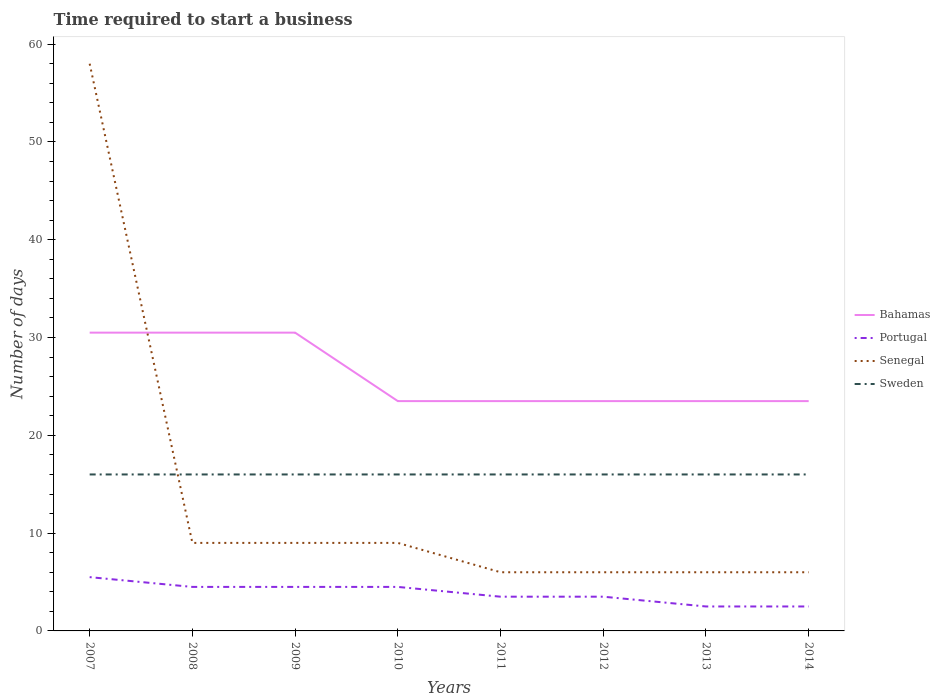Is the number of lines equal to the number of legend labels?
Provide a short and direct response. Yes. Across all years, what is the maximum number of days required to start a business in Portugal?
Give a very brief answer. 2.5. What is the difference between the highest and the second highest number of days required to start a business in Bahamas?
Ensure brevity in your answer.  7. Is the number of days required to start a business in Portugal strictly greater than the number of days required to start a business in Senegal over the years?
Offer a very short reply. Yes. How many lines are there?
Keep it short and to the point. 4. What is the difference between two consecutive major ticks on the Y-axis?
Give a very brief answer. 10. Are the values on the major ticks of Y-axis written in scientific E-notation?
Give a very brief answer. No. Does the graph contain any zero values?
Offer a very short reply. No. Does the graph contain grids?
Your answer should be compact. No. How are the legend labels stacked?
Provide a short and direct response. Vertical. What is the title of the graph?
Make the answer very short. Time required to start a business. Does "Fiji" appear as one of the legend labels in the graph?
Offer a very short reply. No. What is the label or title of the X-axis?
Provide a succinct answer. Years. What is the label or title of the Y-axis?
Keep it short and to the point. Number of days. What is the Number of days in Bahamas in 2007?
Keep it short and to the point. 30.5. What is the Number of days in Portugal in 2007?
Offer a very short reply. 5.5. What is the Number of days of Senegal in 2007?
Give a very brief answer. 58. What is the Number of days of Bahamas in 2008?
Ensure brevity in your answer.  30.5. What is the Number of days of Portugal in 2008?
Give a very brief answer. 4.5. What is the Number of days in Sweden in 2008?
Your answer should be very brief. 16. What is the Number of days of Bahamas in 2009?
Your answer should be very brief. 30.5. What is the Number of days in Portugal in 2009?
Your answer should be compact. 4.5. What is the Number of days of Bahamas in 2010?
Offer a very short reply. 23.5. What is the Number of days in Portugal in 2010?
Offer a very short reply. 4.5. What is the Number of days in Senegal in 2010?
Keep it short and to the point. 9. What is the Number of days in Bahamas in 2011?
Your answer should be very brief. 23.5. What is the Number of days in Senegal in 2011?
Offer a terse response. 6. What is the Number of days of Bahamas in 2012?
Ensure brevity in your answer.  23.5. What is the Number of days in Portugal in 2012?
Keep it short and to the point. 3.5. What is the Number of days in Sweden in 2012?
Offer a terse response. 16. What is the Number of days in Portugal in 2013?
Make the answer very short. 2.5. What is the Number of days in Senegal in 2013?
Offer a terse response. 6. What is the Number of days of Sweden in 2013?
Provide a succinct answer. 16. What is the Number of days in Bahamas in 2014?
Offer a very short reply. 23.5. What is the Number of days in Portugal in 2014?
Your answer should be very brief. 2.5. What is the Number of days in Sweden in 2014?
Your answer should be very brief. 16. Across all years, what is the maximum Number of days in Bahamas?
Make the answer very short. 30.5. Across all years, what is the maximum Number of days of Sweden?
Ensure brevity in your answer.  16. Across all years, what is the minimum Number of days of Bahamas?
Keep it short and to the point. 23.5. Across all years, what is the minimum Number of days of Portugal?
Provide a short and direct response. 2.5. Across all years, what is the minimum Number of days in Senegal?
Provide a short and direct response. 6. Across all years, what is the minimum Number of days of Sweden?
Keep it short and to the point. 16. What is the total Number of days in Bahamas in the graph?
Ensure brevity in your answer.  209. What is the total Number of days in Portugal in the graph?
Offer a terse response. 31. What is the total Number of days of Senegal in the graph?
Your answer should be compact. 109. What is the total Number of days of Sweden in the graph?
Provide a succinct answer. 128. What is the difference between the Number of days in Sweden in 2007 and that in 2008?
Ensure brevity in your answer.  0. What is the difference between the Number of days in Senegal in 2007 and that in 2009?
Keep it short and to the point. 49. What is the difference between the Number of days in Sweden in 2007 and that in 2010?
Offer a terse response. 0. What is the difference between the Number of days of Bahamas in 2007 and that in 2011?
Ensure brevity in your answer.  7. What is the difference between the Number of days of Portugal in 2007 and that in 2011?
Give a very brief answer. 2. What is the difference between the Number of days of Sweden in 2007 and that in 2011?
Give a very brief answer. 0. What is the difference between the Number of days of Portugal in 2007 and that in 2012?
Ensure brevity in your answer.  2. What is the difference between the Number of days of Sweden in 2007 and that in 2012?
Make the answer very short. 0. What is the difference between the Number of days in Senegal in 2007 and that in 2014?
Your answer should be very brief. 52. What is the difference between the Number of days in Sweden in 2007 and that in 2014?
Ensure brevity in your answer.  0. What is the difference between the Number of days of Senegal in 2008 and that in 2009?
Provide a succinct answer. 0. What is the difference between the Number of days of Sweden in 2008 and that in 2009?
Provide a short and direct response. 0. What is the difference between the Number of days in Sweden in 2008 and that in 2010?
Give a very brief answer. 0. What is the difference between the Number of days in Bahamas in 2008 and that in 2011?
Ensure brevity in your answer.  7. What is the difference between the Number of days in Senegal in 2008 and that in 2011?
Keep it short and to the point. 3. What is the difference between the Number of days of Bahamas in 2008 and that in 2012?
Offer a very short reply. 7. What is the difference between the Number of days of Senegal in 2008 and that in 2012?
Provide a short and direct response. 3. What is the difference between the Number of days of Portugal in 2008 and that in 2013?
Keep it short and to the point. 2. What is the difference between the Number of days in Senegal in 2008 and that in 2013?
Offer a very short reply. 3. What is the difference between the Number of days in Bahamas in 2008 and that in 2014?
Keep it short and to the point. 7. What is the difference between the Number of days of Portugal in 2008 and that in 2014?
Keep it short and to the point. 2. What is the difference between the Number of days in Senegal in 2008 and that in 2014?
Provide a short and direct response. 3. What is the difference between the Number of days of Sweden in 2008 and that in 2014?
Give a very brief answer. 0. What is the difference between the Number of days in Bahamas in 2009 and that in 2010?
Provide a short and direct response. 7. What is the difference between the Number of days of Sweden in 2009 and that in 2010?
Make the answer very short. 0. What is the difference between the Number of days of Bahamas in 2009 and that in 2011?
Your response must be concise. 7. What is the difference between the Number of days in Bahamas in 2009 and that in 2012?
Your answer should be very brief. 7. What is the difference between the Number of days of Portugal in 2009 and that in 2012?
Your answer should be very brief. 1. What is the difference between the Number of days of Senegal in 2009 and that in 2012?
Provide a succinct answer. 3. What is the difference between the Number of days in Senegal in 2009 and that in 2013?
Keep it short and to the point. 3. What is the difference between the Number of days in Bahamas in 2010 and that in 2011?
Provide a short and direct response. 0. What is the difference between the Number of days of Portugal in 2010 and that in 2011?
Your answer should be compact. 1. What is the difference between the Number of days in Senegal in 2010 and that in 2011?
Offer a terse response. 3. What is the difference between the Number of days of Sweden in 2010 and that in 2011?
Your answer should be compact. 0. What is the difference between the Number of days of Bahamas in 2010 and that in 2012?
Make the answer very short. 0. What is the difference between the Number of days of Sweden in 2010 and that in 2012?
Your answer should be compact. 0. What is the difference between the Number of days in Bahamas in 2010 and that in 2013?
Provide a short and direct response. 0. What is the difference between the Number of days in Portugal in 2010 and that in 2013?
Give a very brief answer. 2. What is the difference between the Number of days in Senegal in 2010 and that in 2013?
Keep it short and to the point. 3. What is the difference between the Number of days of Senegal in 2010 and that in 2014?
Your response must be concise. 3. What is the difference between the Number of days in Portugal in 2011 and that in 2012?
Give a very brief answer. 0. What is the difference between the Number of days in Senegal in 2011 and that in 2012?
Your answer should be compact. 0. What is the difference between the Number of days in Sweden in 2011 and that in 2012?
Make the answer very short. 0. What is the difference between the Number of days of Bahamas in 2011 and that in 2013?
Your answer should be very brief. 0. What is the difference between the Number of days of Portugal in 2011 and that in 2013?
Provide a succinct answer. 1. What is the difference between the Number of days of Portugal in 2011 and that in 2014?
Keep it short and to the point. 1. What is the difference between the Number of days in Senegal in 2011 and that in 2014?
Give a very brief answer. 0. What is the difference between the Number of days in Sweden in 2011 and that in 2014?
Your answer should be very brief. 0. What is the difference between the Number of days of Bahamas in 2012 and that in 2013?
Make the answer very short. 0. What is the difference between the Number of days in Sweden in 2012 and that in 2013?
Ensure brevity in your answer.  0. What is the difference between the Number of days in Portugal in 2012 and that in 2014?
Your answer should be compact. 1. What is the difference between the Number of days of Sweden in 2012 and that in 2014?
Give a very brief answer. 0. What is the difference between the Number of days in Portugal in 2013 and that in 2014?
Ensure brevity in your answer.  0. What is the difference between the Number of days in Senegal in 2013 and that in 2014?
Provide a succinct answer. 0. What is the difference between the Number of days of Bahamas in 2007 and the Number of days of Portugal in 2008?
Your response must be concise. 26. What is the difference between the Number of days of Bahamas in 2007 and the Number of days of Senegal in 2008?
Offer a very short reply. 21.5. What is the difference between the Number of days of Bahamas in 2007 and the Number of days of Sweden in 2008?
Your answer should be very brief. 14.5. What is the difference between the Number of days of Portugal in 2007 and the Number of days of Senegal in 2008?
Offer a terse response. -3.5. What is the difference between the Number of days of Portugal in 2007 and the Number of days of Sweden in 2008?
Provide a succinct answer. -10.5. What is the difference between the Number of days in Senegal in 2007 and the Number of days in Sweden in 2008?
Your response must be concise. 42. What is the difference between the Number of days of Bahamas in 2007 and the Number of days of Senegal in 2009?
Make the answer very short. 21.5. What is the difference between the Number of days in Bahamas in 2007 and the Number of days in Sweden in 2009?
Your answer should be compact. 14.5. What is the difference between the Number of days in Senegal in 2007 and the Number of days in Sweden in 2009?
Your answer should be very brief. 42. What is the difference between the Number of days of Bahamas in 2007 and the Number of days of Sweden in 2010?
Provide a short and direct response. 14.5. What is the difference between the Number of days in Portugal in 2007 and the Number of days in Sweden in 2010?
Your answer should be very brief. -10.5. What is the difference between the Number of days of Bahamas in 2007 and the Number of days of Portugal in 2011?
Make the answer very short. 27. What is the difference between the Number of days of Bahamas in 2007 and the Number of days of Senegal in 2011?
Offer a very short reply. 24.5. What is the difference between the Number of days of Bahamas in 2007 and the Number of days of Sweden in 2011?
Offer a very short reply. 14.5. What is the difference between the Number of days in Portugal in 2007 and the Number of days in Sweden in 2011?
Give a very brief answer. -10.5. What is the difference between the Number of days of Bahamas in 2007 and the Number of days of Portugal in 2012?
Offer a terse response. 27. What is the difference between the Number of days in Bahamas in 2007 and the Number of days in Senegal in 2012?
Provide a succinct answer. 24.5. What is the difference between the Number of days in Portugal in 2007 and the Number of days in Senegal in 2012?
Make the answer very short. -0.5. What is the difference between the Number of days of Portugal in 2007 and the Number of days of Sweden in 2012?
Give a very brief answer. -10.5. What is the difference between the Number of days of Senegal in 2007 and the Number of days of Sweden in 2012?
Ensure brevity in your answer.  42. What is the difference between the Number of days of Portugal in 2007 and the Number of days of Senegal in 2013?
Make the answer very short. -0.5. What is the difference between the Number of days of Senegal in 2007 and the Number of days of Sweden in 2013?
Give a very brief answer. 42. What is the difference between the Number of days in Bahamas in 2007 and the Number of days in Sweden in 2014?
Provide a succinct answer. 14.5. What is the difference between the Number of days of Portugal in 2007 and the Number of days of Sweden in 2014?
Offer a very short reply. -10.5. What is the difference between the Number of days in Portugal in 2008 and the Number of days in Senegal in 2009?
Provide a succinct answer. -4.5. What is the difference between the Number of days in Senegal in 2008 and the Number of days in Sweden in 2009?
Give a very brief answer. -7. What is the difference between the Number of days of Bahamas in 2008 and the Number of days of Portugal in 2010?
Ensure brevity in your answer.  26. What is the difference between the Number of days of Bahamas in 2008 and the Number of days of Sweden in 2010?
Keep it short and to the point. 14.5. What is the difference between the Number of days in Portugal in 2008 and the Number of days in Senegal in 2010?
Provide a short and direct response. -4.5. What is the difference between the Number of days of Portugal in 2008 and the Number of days of Sweden in 2010?
Make the answer very short. -11.5. What is the difference between the Number of days of Senegal in 2008 and the Number of days of Sweden in 2010?
Your answer should be compact. -7. What is the difference between the Number of days in Bahamas in 2008 and the Number of days in Portugal in 2011?
Your answer should be compact. 27. What is the difference between the Number of days of Bahamas in 2008 and the Number of days of Senegal in 2011?
Provide a short and direct response. 24.5. What is the difference between the Number of days in Portugal in 2008 and the Number of days in Senegal in 2011?
Your answer should be compact. -1.5. What is the difference between the Number of days in Portugal in 2008 and the Number of days in Sweden in 2011?
Your response must be concise. -11.5. What is the difference between the Number of days of Senegal in 2008 and the Number of days of Sweden in 2011?
Your answer should be compact. -7. What is the difference between the Number of days in Bahamas in 2008 and the Number of days in Senegal in 2012?
Your answer should be compact. 24.5. What is the difference between the Number of days in Bahamas in 2008 and the Number of days in Sweden in 2012?
Give a very brief answer. 14.5. What is the difference between the Number of days in Bahamas in 2008 and the Number of days in Portugal in 2013?
Offer a very short reply. 28. What is the difference between the Number of days of Bahamas in 2008 and the Number of days of Sweden in 2013?
Your answer should be compact. 14.5. What is the difference between the Number of days in Portugal in 2008 and the Number of days in Senegal in 2013?
Provide a succinct answer. -1.5. What is the difference between the Number of days of Portugal in 2008 and the Number of days of Sweden in 2013?
Provide a succinct answer. -11.5. What is the difference between the Number of days of Senegal in 2008 and the Number of days of Sweden in 2013?
Your answer should be very brief. -7. What is the difference between the Number of days of Bahamas in 2008 and the Number of days of Portugal in 2014?
Your response must be concise. 28. What is the difference between the Number of days in Bahamas in 2008 and the Number of days in Senegal in 2014?
Ensure brevity in your answer.  24.5. What is the difference between the Number of days of Bahamas in 2008 and the Number of days of Sweden in 2014?
Offer a terse response. 14.5. What is the difference between the Number of days of Bahamas in 2009 and the Number of days of Portugal in 2010?
Offer a terse response. 26. What is the difference between the Number of days in Bahamas in 2009 and the Number of days in Senegal in 2010?
Offer a terse response. 21.5. What is the difference between the Number of days of Bahamas in 2009 and the Number of days of Sweden in 2010?
Give a very brief answer. 14.5. What is the difference between the Number of days of Portugal in 2009 and the Number of days of Senegal in 2010?
Offer a very short reply. -4.5. What is the difference between the Number of days in Portugal in 2009 and the Number of days in Sweden in 2010?
Your answer should be compact. -11.5. What is the difference between the Number of days of Senegal in 2009 and the Number of days of Sweden in 2010?
Provide a short and direct response. -7. What is the difference between the Number of days of Bahamas in 2009 and the Number of days of Portugal in 2011?
Provide a short and direct response. 27. What is the difference between the Number of days in Bahamas in 2009 and the Number of days in Sweden in 2011?
Your answer should be very brief. 14.5. What is the difference between the Number of days of Portugal in 2009 and the Number of days of Senegal in 2011?
Ensure brevity in your answer.  -1.5. What is the difference between the Number of days of Senegal in 2009 and the Number of days of Sweden in 2011?
Your response must be concise. -7. What is the difference between the Number of days of Bahamas in 2009 and the Number of days of Portugal in 2012?
Provide a short and direct response. 27. What is the difference between the Number of days in Bahamas in 2009 and the Number of days in Senegal in 2012?
Offer a very short reply. 24.5. What is the difference between the Number of days of Bahamas in 2009 and the Number of days of Sweden in 2012?
Ensure brevity in your answer.  14.5. What is the difference between the Number of days in Portugal in 2009 and the Number of days in Senegal in 2012?
Ensure brevity in your answer.  -1.5. What is the difference between the Number of days of Portugal in 2009 and the Number of days of Sweden in 2012?
Keep it short and to the point. -11.5. What is the difference between the Number of days in Bahamas in 2009 and the Number of days in Portugal in 2013?
Offer a terse response. 28. What is the difference between the Number of days of Bahamas in 2009 and the Number of days of Senegal in 2013?
Make the answer very short. 24.5. What is the difference between the Number of days in Portugal in 2009 and the Number of days in Senegal in 2013?
Give a very brief answer. -1.5. What is the difference between the Number of days in Portugal in 2009 and the Number of days in Sweden in 2013?
Give a very brief answer. -11.5. What is the difference between the Number of days of Senegal in 2009 and the Number of days of Sweden in 2013?
Make the answer very short. -7. What is the difference between the Number of days in Bahamas in 2009 and the Number of days in Senegal in 2014?
Give a very brief answer. 24.5. What is the difference between the Number of days in Bahamas in 2010 and the Number of days in Senegal in 2011?
Provide a succinct answer. 17.5. What is the difference between the Number of days of Portugal in 2010 and the Number of days of Senegal in 2011?
Keep it short and to the point. -1.5. What is the difference between the Number of days of Portugal in 2010 and the Number of days of Sweden in 2011?
Offer a very short reply. -11.5. What is the difference between the Number of days in Bahamas in 2010 and the Number of days in Senegal in 2012?
Provide a short and direct response. 17.5. What is the difference between the Number of days of Portugal in 2010 and the Number of days of Senegal in 2012?
Give a very brief answer. -1.5. What is the difference between the Number of days of Portugal in 2010 and the Number of days of Sweden in 2012?
Offer a very short reply. -11.5. What is the difference between the Number of days of Bahamas in 2010 and the Number of days of Senegal in 2013?
Your answer should be compact. 17.5. What is the difference between the Number of days in Portugal in 2010 and the Number of days in Sweden in 2013?
Provide a short and direct response. -11.5. What is the difference between the Number of days in Senegal in 2010 and the Number of days in Sweden in 2013?
Provide a succinct answer. -7. What is the difference between the Number of days in Portugal in 2010 and the Number of days in Sweden in 2014?
Your answer should be compact. -11.5. What is the difference between the Number of days of Senegal in 2010 and the Number of days of Sweden in 2014?
Make the answer very short. -7. What is the difference between the Number of days of Bahamas in 2011 and the Number of days of Portugal in 2012?
Your response must be concise. 20. What is the difference between the Number of days of Bahamas in 2011 and the Number of days of Senegal in 2012?
Make the answer very short. 17.5. What is the difference between the Number of days of Bahamas in 2011 and the Number of days of Sweden in 2012?
Keep it short and to the point. 7.5. What is the difference between the Number of days in Portugal in 2011 and the Number of days in Senegal in 2012?
Provide a succinct answer. -2.5. What is the difference between the Number of days of Portugal in 2011 and the Number of days of Sweden in 2012?
Keep it short and to the point. -12.5. What is the difference between the Number of days of Senegal in 2011 and the Number of days of Sweden in 2012?
Provide a succinct answer. -10. What is the difference between the Number of days in Bahamas in 2011 and the Number of days in Senegal in 2013?
Make the answer very short. 17.5. What is the difference between the Number of days in Portugal in 2011 and the Number of days in Sweden in 2013?
Offer a very short reply. -12.5. What is the difference between the Number of days in Portugal in 2011 and the Number of days in Senegal in 2014?
Provide a short and direct response. -2.5. What is the difference between the Number of days of Bahamas in 2012 and the Number of days of Sweden in 2013?
Provide a succinct answer. 7.5. What is the difference between the Number of days in Portugal in 2012 and the Number of days in Senegal in 2013?
Provide a short and direct response. -2.5. What is the difference between the Number of days of Bahamas in 2012 and the Number of days of Portugal in 2014?
Your response must be concise. 21. What is the difference between the Number of days in Bahamas in 2012 and the Number of days in Sweden in 2014?
Your response must be concise. 7.5. What is the difference between the Number of days in Senegal in 2012 and the Number of days in Sweden in 2014?
Your response must be concise. -10. What is the average Number of days in Bahamas per year?
Keep it short and to the point. 26.12. What is the average Number of days in Portugal per year?
Make the answer very short. 3.88. What is the average Number of days of Senegal per year?
Offer a very short reply. 13.62. What is the average Number of days of Sweden per year?
Give a very brief answer. 16. In the year 2007, what is the difference between the Number of days of Bahamas and Number of days of Portugal?
Make the answer very short. 25. In the year 2007, what is the difference between the Number of days in Bahamas and Number of days in Senegal?
Your answer should be very brief. -27.5. In the year 2007, what is the difference between the Number of days of Bahamas and Number of days of Sweden?
Offer a very short reply. 14.5. In the year 2007, what is the difference between the Number of days in Portugal and Number of days in Senegal?
Your answer should be very brief. -52.5. In the year 2007, what is the difference between the Number of days in Senegal and Number of days in Sweden?
Offer a very short reply. 42. In the year 2008, what is the difference between the Number of days in Bahamas and Number of days in Portugal?
Make the answer very short. 26. In the year 2008, what is the difference between the Number of days of Portugal and Number of days of Sweden?
Your response must be concise. -11.5. In the year 2008, what is the difference between the Number of days in Senegal and Number of days in Sweden?
Ensure brevity in your answer.  -7. In the year 2009, what is the difference between the Number of days in Bahamas and Number of days in Portugal?
Ensure brevity in your answer.  26. In the year 2009, what is the difference between the Number of days in Portugal and Number of days in Senegal?
Your response must be concise. -4.5. In the year 2009, what is the difference between the Number of days in Portugal and Number of days in Sweden?
Offer a terse response. -11.5. In the year 2010, what is the difference between the Number of days in Bahamas and Number of days in Portugal?
Offer a terse response. 19. In the year 2010, what is the difference between the Number of days of Portugal and Number of days of Senegal?
Your answer should be compact. -4.5. In the year 2011, what is the difference between the Number of days of Bahamas and Number of days of Senegal?
Make the answer very short. 17.5. In the year 2011, what is the difference between the Number of days in Portugal and Number of days in Sweden?
Your answer should be very brief. -12.5. In the year 2012, what is the difference between the Number of days of Bahamas and Number of days of Senegal?
Offer a very short reply. 17.5. In the year 2012, what is the difference between the Number of days of Portugal and Number of days of Sweden?
Make the answer very short. -12.5. In the year 2012, what is the difference between the Number of days of Senegal and Number of days of Sweden?
Make the answer very short. -10. In the year 2013, what is the difference between the Number of days in Bahamas and Number of days in Portugal?
Make the answer very short. 21. In the year 2013, what is the difference between the Number of days in Portugal and Number of days in Senegal?
Keep it short and to the point. -3.5. In the year 2013, what is the difference between the Number of days in Portugal and Number of days in Sweden?
Ensure brevity in your answer.  -13.5. In the year 2014, what is the difference between the Number of days of Bahamas and Number of days of Portugal?
Provide a short and direct response. 21. In the year 2014, what is the difference between the Number of days of Portugal and Number of days of Sweden?
Ensure brevity in your answer.  -13.5. What is the ratio of the Number of days of Portugal in 2007 to that in 2008?
Provide a short and direct response. 1.22. What is the ratio of the Number of days in Senegal in 2007 to that in 2008?
Offer a terse response. 6.44. What is the ratio of the Number of days in Portugal in 2007 to that in 2009?
Make the answer very short. 1.22. What is the ratio of the Number of days in Senegal in 2007 to that in 2009?
Your response must be concise. 6.44. What is the ratio of the Number of days of Bahamas in 2007 to that in 2010?
Provide a short and direct response. 1.3. What is the ratio of the Number of days in Portugal in 2007 to that in 2010?
Ensure brevity in your answer.  1.22. What is the ratio of the Number of days of Senegal in 2007 to that in 2010?
Offer a terse response. 6.44. What is the ratio of the Number of days of Sweden in 2007 to that in 2010?
Your response must be concise. 1. What is the ratio of the Number of days in Bahamas in 2007 to that in 2011?
Offer a terse response. 1.3. What is the ratio of the Number of days in Portugal in 2007 to that in 2011?
Make the answer very short. 1.57. What is the ratio of the Number of days in Senegal in 2007 to that in 2011?
Your answer should be very brief. 9.67. What is the ratio of the Number of days in Sweden in 2007 to that in 2011?
Offer a terse response. 1. What is the ratio of the Number of days of Bahamas in 2007 to that in 2012?
Offer a terse response. 1.3. What is the ratio of the Number of days in Portugal in 2007 to that in 2012?
Offer a terse response. 1.57. What is the ratio of the Number of days of Senegal in 2007 to that in 2012?
Offer a terse response. 9.67. What is the ratio of the Number of days in Sweden in 2007 to that in 2012?
Offer a terse response. 1. What is the ratio of the Number of days of Bahamas in 2007 to that in 2013?
Your response must be concise. 1.3. What is the ratio of the Number of days in Portugal in 2007 to that in 2013?
Make the answer very short. 2.2. What is the ratio of the Number of days of Senegal in 2007 to that in 2013?
Your answer should be compact. 9.67. What is the ratio of the Number of days of Sweden in 2007 to that in 2013?
Provide a short and direct response. 1. What is the ratio of the Number of days in Bahamas in 2007 to that in 2014?
Provide a succinct answer. 1.3. What is the ratio of the Number of days in Portugal in 2007 to that in 2014?
Ensure brevity in your answer.  2.2. What is the ratio of the Number of days of Senegal in 2007 to that in 2014?
Make the answer very short. 9.67. What is the ratio of the Number of days of Sweden in 2007 to that in 2014?
Offer a very short reply. 1. What is the ratio of the Number of days of Bahamas in 2008 to that in 2009?
Your answer should be compact. 1. What is the ratio of the Number of days in Portugal in 2008 to that in 2009?
Ensure brevity in your answer.  1. What is the ratio of the Number of days of Senegal in 2008 to that in 2009?
Make the answer very short. 1. What is the ratio of the Number of days of Bahamas in 2008 to that in 2010?
Your answer should be very brief. 1.3. What is the ratio of the Number of days in Portugal in 2008 to that in 2010?
Your answer should be very brief. 1. What is the ratio of the Number of days of Bahamas in 2008 to that in 2011?
Offer a very short reply. 1.3. What is the ratio of the Number of days in Senegal in 2008 to that in 2011?
Offer a terse response. 1.5. What is the ratio of the Number of days of Sweden in 2008 to that in 2011?
Keep it short and to the point. 1. What is the ratio of the Number of days of Bahamas in 2008 to that in 2012?
Make the answer very short. 1.3. What is the ratio of the Number of days in Senegal in 2008 to that in 2012?
Your response must be concise. 1.5. What is the ratio of the Number of days of Sweden in 2008 to that in 2012?
Offer a very short reply. 1. What is the ratio of the Number of days in Bahamas in 2008 to that in 2013?
Keep it short and to the point. 1.3. What is the ratio of the Number of days in Senegal in 2008 to that in 2013?
Your response must be concise. 1.5. What is the ratio of the Number of days of Bahamas in 2008 to that in 2014?
Offer a terse response. 1.3. What is the ratio of the Number of days in Portugal in 2008 to that in 2014?
Your response must be concise. 1.8. What is the ratio of the Number of days of Bahamas in 2009 to that in 2010?
Your answer should be very brief. 1.3. What is the ratio of the Number of days of Portugal in 2009 to that in 2010?
Provide a succinct answer. 1. What is the ratio of the Number of days in Bahamas in 2009 to that in 2011?
Keep it short and to the point. 1.3. What is the ratio of the Number of days of Sweden in 2009 to that in 2011?
Offer a very short reply. 1. What is the ratio of the Number of days in Bahamas in 2009 to that in 2012?
Ensure brevity in your answer.  1.3. What is the ratio of the Number of days of Portugal in 2009 to that in 2012?
Give a very brief answer. 1.29. What is the ratio of the Number of days in Senegal in 2009 to that in 2012?
Keep it short and to the point. 1.5. What is the ratio of the Number of days of Sweden in 2009 to that in 2012?
Ensure brevity in your answer.  1. What is the ratio of the Number of days in Bahamas in 2009 to that in 2013?
Your response must be concise. 1.3. What is the ratio of the Number of days of Portugal in 2009 to that in 2013?
Provide a short and direct response. 1.8. What is the ratio of the Number of days of Senegal in 2009 to that in 2013?
Make the answer very short. 1.5. What is the ratio of the Number of days in Sweden in 2009 to that in 2013?
Offer a very short reply. 1. What is the ratio of the Number of days in Bahamas in 2009 to that in 2014?
Your response must be concise. 1.3. What is the ratio of the Number of days in Sweden in 2010 to that in 2011?
Keep it short and to the point. 1. What is the ratio of the Number of days in Bahamas in 2010 to that in 2012?
Ensure brevity in your answer.  1. What is the ratio of the Number of days in Bahamas in 2010 to that in 2013?
Ensure brevity in your answer.  1. What is the ratio of the Number of days of Senegal in 2010 to that in 2014?
Provide a short and direct response. 1.5. What is the ratio of the Number of days of Sweden in 2010 to that in 2014?
Offer a very short reply. 1. What is the ratio of the Number of days of Bahamas in 2011 to that in 2012?
Your answer should be very brief. 1. What is the ratio of the Number of days of Senegal in 2011 to that in 2012?
Keep it short and to the point. 1. What is the ratio of the Number of days in Portugal in 2011 to that in 2013?
Make the answer very short. 1.4. What is the ratio of the Number of days in Senegal in 2011 to that in 2013?
Keep it short and to the point. 1. What is the ratio of the Number of days of Bahamas in 2011 to that in 2014?
Offer a very short reply. 1. What is the ratio of the Number of days in Portugal in 2012 to that in 2013?
Provide a short and direct response. 1.4. What is the ratio of the Number of days of Bahamas in 2012 to that in 2014?
Offer a terse response. 1. What is the ratio of the Number of days in Senegal in 2012 to that in 2014?
Offer a terse response. 1. What is the ratio of the Number of days of Sweden in 2012 to that in 2014?
Offer a terse response. 1. What is the ratio of the Number of days of Bahamas in 2013 to that in 2014?
Your response must be concise. 1. What is the difference between the highest and the lowest Number of days in Senegal?
Offer a terse response. 52. What is the difference between the highest and the lowest Number of days of Sweden?
Provide a succinct answer. 0. 